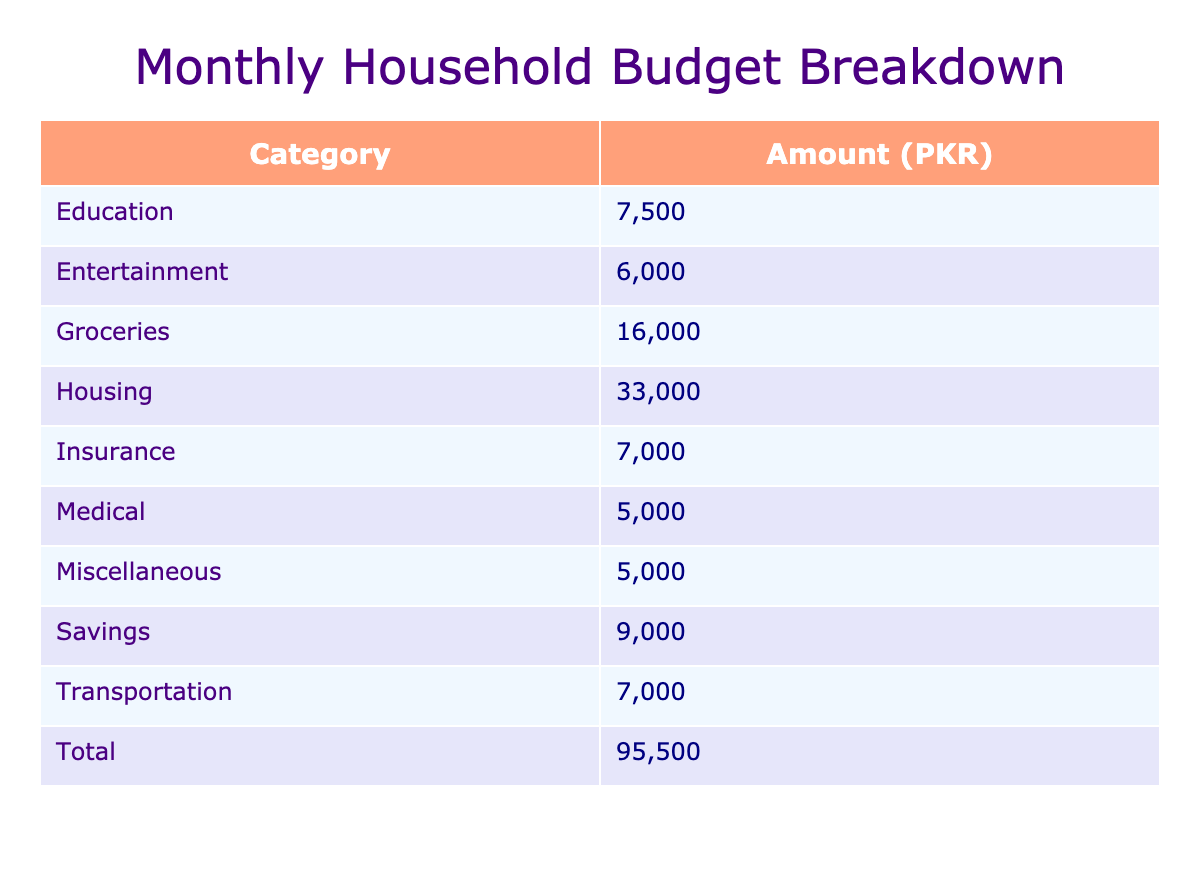What is the total amount spent on Housing? The Housing category has three items: Rent/Mortgage (25000), Utilities (5000), and Repairs/Maintenance (3000). Summing these amounts gives us: 25000 + 5000 + 3000 = 33000 PKR.
Answer: 33000 PKR What is the biggest expense in the Transportation category? In the Transportation category, the items and their amounts are: Gasoline (4000), Vehicle Maintenance (2000), and Public Transport (1000). The maximum value among these is Gasoline at 4000 PKR.
Answer: 4000 PKR Is the total amount spent on Medical expenses more than 10000 PKR? The Medical category includes Prescription Medications (3000) and Doctor's Visits (2000). Summing these, we get 3000 + 2000 = 5000 PKR. Since 5000 is less than 10000, the answer is no.
Answer: No What is the average amount spent on groceries? In the Groceries category, there are four items: Fresh Produce (6000), Meat/Poultry (5000), Dairy Products (3000), and Grains/Cereals (2000). We first sum these amounts: 6000 + 5000 + 3000 + 2000 = 16000 PKR. There are four items, so the average is 16000/4 = 4000 PKR.
Answer: 4000 PKR How much is spent on Insurance in total? The Insurance category has three items: Health Insurance (4000), Vehicle Insurance (2000), and Home Insurance (1000). Adding these together gives us: 4000 + 2000 + 1000 = 7000 PKR.
Answer: 7000 PKR Which category has the lowest total expenditure? Each category's total expenditure is calculated as follows: Housing (33000), Transportation (7000), Groceries (16000), Medical (5000), Insurance (7000), Entertainment (6000), Education (7500), Savings (9000), and Miscellaneous (5000). The lowest total is Medical with 5000 PKR.
Answer: Medical Is the amount allocated to Savings greater than that allocated to Education? The Savings category totals 4000 (Emergency Fund) + 5000 (Retirement Fund) = 9000 PKR. The Education category totals 2500 (Books/Supplies) + 5000 (Tuition Fees) = 7500 PKR. Since 9000 is greater than 7500, the answer is yes.
Answer: Yes What proportion of the total budget is spent on Entertainment? First, we calculate the total budget, which is 25000 (Housing) + 7000 (Transportation) + 16000 (Groceries) + 5000 (Medical) + 7000 (Insurance) + 6000 (Entertainment) + 7500 (Education) + 9000 (Savings) + 5000 (Miscellaneous) = 125500 PKR. The total spent on Entertainment is 6000 PKR. The proportion is (6000/125500) * 100 = 4.78%.
Answer: 4.78% 